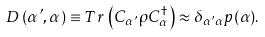Convert formula to latex. <formula><loc_0><loc_0><loc_500><loc_500>D \left ( \alpha ^ { \prime } , \alpha \right ) \equiv T r \, \left ( C _ { \alpha ^ { \prime } } \rho C ^ { \dagger } _ { \alpha } \right ) \approx \delta _ { \alpha ^ { \prime } \alpha } p ( \alpha ) .</formula> 